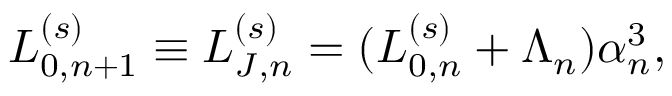<formula> <loc_0><loc_0><loc_500><loc_500>L _ { 0 , n + 1 } ^ { ( s ) } \equiv L _ { J , n } ^ { ( s ) } = ( L _ { 0 , n } ^ { ( s ) } + \Lambda _ { n } ) \alpha _ { n } ^ { 3 } ,</formula> 